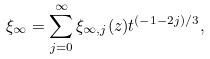<formula> <loc_0><loc_0><loc_500><loc_500>\xi _ { \infty } = \sum _ { j = 0 } ^ { \infty } \xi _ { \infty , j } ( z ) t ^ { ( - 1 - 2 j ) / 3 } ,</formula> 